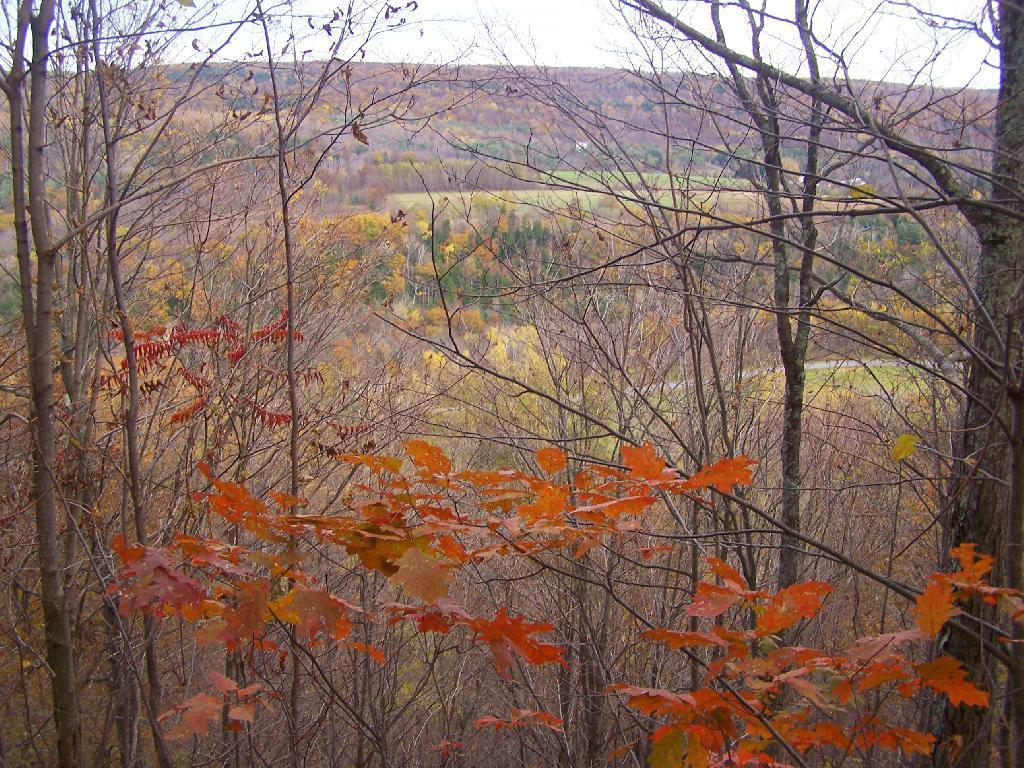What is located in the foreground of the image? There are plants in the foreground of the image. What can be seen in the background of the image? There are many trees and a mountain visible in the background of the image. Where can you find a park in the image? There is no park present in the image; it features plants, trees, and a mountain. What type of drink is being served in the image? There is no drink present in the image. Can you see a brush in the image? There is no brush present in the image. 